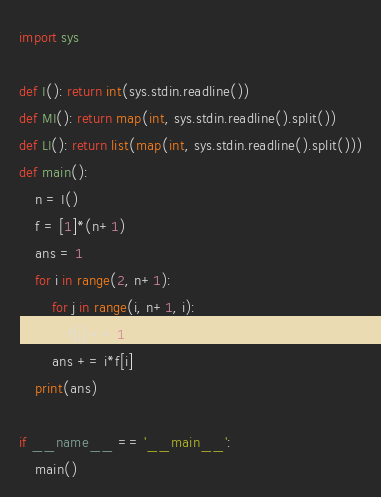<code> <loc_0><loc_0><loc_500><loc_500><_Python_>import sys

def I(): return int(sys.stdin.readline())
def MI(): return map(int, sys.stdin.readline().split())
def LI(): return list(map(int, sys.stdin.readline().split()))
def main():
    n = I()
    f = [1]*(n+1)
    ans = 1
    for i in range(2, n+1):
        for j in range(i, n+1, i):
            f[j] += 1
        ans += i*f[i]
    print(ans)

if __name__ == '__main__':
    main()</code> 